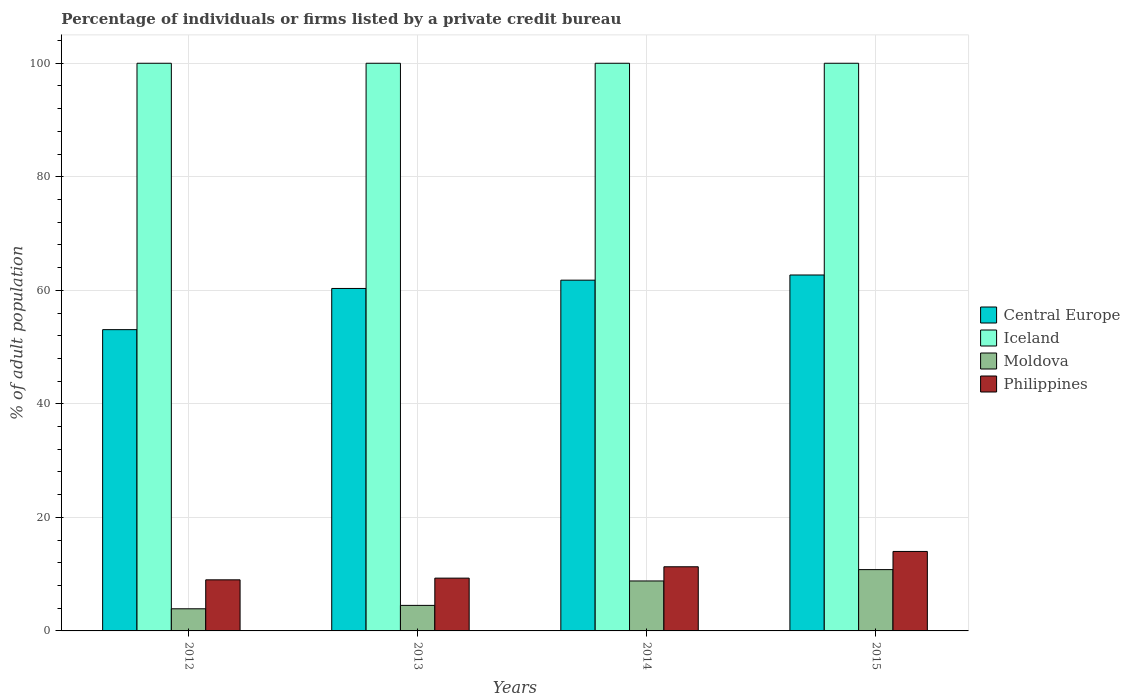How many different coloured bars are there?
Provide a short and direct response. 4. How many groups of bars are there?
Provide a short and direct response. 4. Are the number of bars per tick equal to the number of legend labels?
Provide a succinct answer. Yes. How many bars are there on the 1st tick from the left?
Your response must be concise. 4. How many bars are there on the 3rd tick from the right?
Offer a very short reply. 4. In how many cases, is the number of bars for a given year not equal to the number of legend labels?
Ensure brevity in your answer.  0. Across all years, what is the maximum percentage of population listed by a private credit bureau in Moldova?
Your response must be concise. 10.8. Across all years, what is the minimum percentage of population listed by a private credit bureau in Iceland?
Provide a short and direct response. 100. In which year was the percentage of population listed by a private credit bureau in Central Europe maximum?
Ensure brevity in your answer.  2015. What is the total percentage of population listed by a private credit bureau in Philippines in the graph?
Offer a very short reply. 43.6. What is the difference between the percentage of population listed by a private credit bureau in Philippines in 2014 and that in 2015?
Make the answer very short. -2.7. What is the difference between the percentage of population listed by a private credit bureau in Central Europe in 2015 and the percentage of population listed by a private credit bureau in Moldova in 2013?
Your answer should be very brief. 58.2. What is the average percentage of population listed by a private credit bureau in Philippines per year?
Give a very brief answer. 10.9. In the year 2012, what is the difference between the percentage of population listed by a private credit bureau in Philippines and percentage of population listed by a private credit bureau in Moldova?
Give a very brief answer. 5.1. What is the ratio of the percentage of population listed by a private credit bureau in Iceland in 2012 to that in 2015?
Give a very brief answer. 1. Is the difference between the percentage of population listed by a private credit bureau in Philippines in 2012 and 2014 greater than the difference between the percentage of population listed by a private credit bureau in Moldova in 2012 and 2014?
Your response must be concise. Yes. What is the difference between the highest and the second highest percentage of population listed by a private credit bureau in Philippines?
Your answer should be very brief. 2.7. What is the difference between the highest and the lowest percentage of population listed by a private credit bureau in Central Europe?
Make the answer very short. 9.63. Is it the case that in every year, the sum of the percentage of population listed by a private credit bureau in Iceland and percentage of population listed by a private credit bureau in Philippines is greater than the sum of percentage of population listed by a private credit bureau in Central Europe and percentage of population listed by a private credit bureau in Moldova?
Offer a terse response. Yes. What does the 3rd bar from the left in 2015 represents?
Provide a short and direct response. Moldova. What does the 4th bar from the right in 2015 represents?
Offer a terse response. Central Europe. Is it the case that in every year, the sum of the percentage of population listed by a private credit bureau in Philippines and percentage of population listed by a private credit bureau in Moldova is greater than the percentage of population listed by a private credit bureau in Iceland?
Provide a short and direct response. No. Are all the bars in the graph horizontal?
Offer a very short reply. No. How many years are there in the graph?
Give a very brief answer. 4. What is the difference between two consecutive major ticks on the Y-axis?
Offer a very short reply. 20. Where does the legend appear in the graph?
Offer a terse response. Center right. What is the title of the graph?
Your answer should be compact. Percentage of individuals or firms listed by a private credit bureau. What is the label or title of the Y-axis?
Provide a succinct answer. % of adult population. What is the % of adult population of Central Europe in 2012?
Offer a very short reply. 53.07. What is the % of adult population of Central Europe in 2013?
Offer a terse response. 60.33. What is the % of adult population of Moldova in 2013?
Provide a short and direct response. 4.5. What is the % of adult population of Philippines in 2013?
Offer a terse response. 9.3. What is the % of adult population in Central Europe in 2014?
Offer a very short reply. 61.79. What is the % of adult population of Central Europe in 2015?
Offer a very short reply. 62.7. Across all years, what is the maximum % of adult population of Central Europe?
Your answer should be very brief. 62.7. Across all years, what is the maximum % of adult population of Philippines?
Your answer should be compact. 14. Across all years, what is the minimum % of adult population of Central Europe?
Provide a short and direct response. 53.07. Across all years, what is the minimum % of adult population of Moldova?
Give a very brief answer. 3.9. Across all years, what is the minimum % of adult population of Philippines?
Offer a very short reply. 9. What is the total % of adult population in Central Europe in the graph?
Offer a terse response. 237.89. What is the total % of adult population in Philippines in the graph?
Make the answer very short. 43.6. What is the difference between the % of adult population in Central Europe in 2012 and that in 2013?
Make the answer very short. -7.25. What is the difference between the % of adult population of Moldova in 2012 and that in 2013?
Provide a succinct answer. -0.6. What is the difference between the % of adult population in Central Europe in 2012 and that in 2014?
Make the answer very short. -8.72. What is the difference between the % of adult population in Iceland in 2012 and that in 2014?
Your answer should be compact. 0. What is the difference between the % of adult population in Moldova in 2012 and that in 2014?
Provide a short and direct response. -4.9. What is the difference between the % of adult population in Central Europe in 2012 and that in 2015?
Ensure brevity in your answer.  -9.63. What is the difference between the % of adult population of Iceland in 2012 and that in 2015?
Provide a succinct answer. 0. What is the difference between the % of adult population of Moldova in 2012 and that in 2015?
Make the answer very short. -6.9. What is the difference between the % of adult population of Central Europe in 2013 and that in 2014?
Offer a very short reply. -1.46. What is the difference between the % of adult population of Central Europe in 2013 and that in 2015?
Give a very brief answer. -2.37. What is the difference between the % of adult population of Iceland in 2013 and that in 2015?
Your response must be concise. 0. What is the difference between the % of adult population of Moldova in 2013 and that in 2015?
Ensure brevity in your answer.  -6.3. What is the difference between the % of adult population in Philippines in 2013 and that in 2015?
Your response must be concise. -4.7. What is the difference between the % of adult population in Central Europe in 2014 and that in 2015?
Provide a short and direct response. -0.91. What is the difference between the % of adult population in Moldova in 2014 and that in 2015?
Give a very brief answer. -2. What is the difference between the % of adult population of Central Europe in 2012 and the % of adult population of Iceland in 2013?
Keep it short and to the point. -46.93. What is the difference between the % of adult population of Central Europe in 2012 and the % of adult population of Moldova in 2013?
Provide a succinct answer. 48.57. What is the difference between the % of adult population of Central Europe in 2012 and the % of adult population of Philippines in 2013?
Your answer should be very brief. 43.77. What is the difference between the % of adult population in Iceland in 2012 and the % of adult population in Moldova in 2013?
Keep it short and to the point. 95.5. What is the difference between the % of adult population in Iceland in 2012 and the % of adult population in Philippines in 2013?
Give a very brief answer. 90.7. What is the difference between the % of adult population in Moldova in 2012 and the % of adult population in Philippines in 2013?
Offer a terse response. -5.4. What is the difference between the % of adult population of Central Europe in 2012 and the % of adult population of Iceland in 2014?
Keep it short and to the point. -46.93. What is the difference between the % of adult population in Central Europe in 2012 and the % of adult population in Moldova in 2014?
Your answer should be very brief. 44.27. What is the difference between the % of adult population of Central Europe in 2012 and the % of adult population of Philippines in 2014?
Your answer should be compact. 41.77. What is the difference between the % of adult population in Iceland in 2012 and the % of adult population in Moldova in 2014?
Your answer should be very brief. 91.2. What is the difference between the % of adult population in Iceland in 2012 and the % of adult population in Philippines in 2014?
Your response must be concise. 88.7. What is the difference between the % of adult population in Central Europe in 2012 and the % of adult population in Iceland in 2015?
Keep it short and to the point. -46.93. What is the difference between the % of adult population in Central Europe in 2012 and the % of adult population in Moldova in 2015?
Offer a terse response. 42.27. What is the difference between the % of adult population of Central Europe in 2012 and the % of adult population of Philippines in 2015?
Ensure brevity in your answer.  39.07. What is the difference between the % of adult population in Iceland in 2012 and the % of adult population in Moldova in 2015?
Provide a succinct answer. 89.2. What is the difference between the % of adult population in Moldova in 2012 and the % of adult population in Philippines in 2015?
Give a very brief answer. -10.1. What is the difference between the % of adult population of Central Europe in 2013 and the % of adult population of Iceland in 2014?
Provide a succinct answer. -39.67. What is the difference between the % of adult population of Central Europe in 2013 and the % of adult population of Moldova in 2014?
Your answer should be compact. 51.53. What is the difference between the % of adult population of Central Europe in 2013 and the % of adult population of Philippines in 2014?
Provide a short and direct response. 49.03. What is the difference between the % of adult population of Iceland in 2013 and the % of adult population of Moldova in 2014?
Ensure brevity in your answer.  91.2. What is the difference between the % of adult population in Iceland in 2013 and the % of adult population in Philippines in 2014?
Make the answer very short. 88.7. What is the difference between the % of adult population in Moldova in 2013 and the % of adult population in Philippines in 2014?
Your answer should be compact. -6.8. What is the difference between the % of adult population in Central Europe in 2013 and the % of adult population in Iceland in 2015?
Keep it short and to the point. -39.67. What is the difference between the % of adult population of Central Europe in 2013 and the % of adult population of Moldova in 2015?
Offer a very short reply. 49.53. What is the difference between the % of adult population in Central Europe in 2013 and the % of adult population in Philippines in 2015?
Offer a very short reply. 46.33. What is the difference between the % of adult population in Iceland in 2013 and the % of adult population in Moldova in 2015?
Your answer should be compact. 89.2. What is the difference between the % of adult population in Central Europe in 2014 and the % of adult population in Iceland in 2015?
Give a very brief answer. -38.21. What is the difference between the % of adult population in Central Europe in 2014 and the % of adult population in Moldova in 2015?
Your answer should be very brief. 50.99. What is the difference between the % of adult population of Central Europe in 2014 and the % of adult population of Philippines in 2015?
Ensure brevity in your answer.  47.79. What is the difference between the % of adult population of Iceland in 2014 and the % of adult population of Moldova in 2015?
Offer a terse response. 89.2. What is the difference between the % of adult population in Iceland in 2014 and the % of adult population in Philippines in 2015?
Provide a succinct answer. 86. What is the difference between the % of adult population in Moldova in 2014 and the % of adult population in Philippines in 2015?
Ensure brevity in your answer.  -5.2. What is the average % of adult population of Central Europe per year?
Offer a terse response. 59.47. In the year 2012, what is the difference between the % of adult population of Central Europe and % of adult population of Iceland?
Offer a terse response. -46.93. In the year 2012, what is the difference between the % of adult population in Central Europe and % of adult population in Moldova?
Offer a very short reply. 49.17. In the year 2012, what is the difference between the % of adult population of Central Europe and % of adult population of Philippines?
Your answer should be compact. 44.07. In the year 2012, what is the difference between the % of adult population in Iceland and % of adult population in Moldova?
Provide a short and direct response. 96.1. In the year 2012, what is the difference between the % of adult population in Iceland and % of adult population in Philippines?
Ensure brevity in your answer.  91. In the year 2012, what is the difference between the % of adult population of Moldova and % of adult population of Philippines?
Give a very brief answer. -5.1. In the year 2013, what is the difference between the % of adult population of Central Europe and % of adult population of Iceland?
Provide a short and direct response. -39.67. In the year 2013, what is the difference between the % of adult population in Central Europe and % of adult population in Moldova?
Provide a succinct answer. 55.83. In the year 2013, what is the difference between the % of adult population of Central Europe and % of adult population of Philippines?
Your answer should be very brief. 51.03. In the year 2013, what is the difference between the % of adult population in Iceland and % of adult population in Moldova?
Your answer should be compact. 95.5. In the year 2013, what is the difference between the % of adult population of Iceland and % of adult population of Philippines?
Give a very brief answer. 90.7. In the year 2014, what is the difference between the % of adult population in Central Europe and % of adult population in Iceland?
Offer a very short reply. -38.21. In the year 2014, what is the difference between the % of adult population in Central Europe and % of adult population in Moldova?
Offer a very short reply. 52.99. In the year 2014, what is the difference between the % of adult population in Central Europe and % of adult population in Philippines?
Your answer should be compact. 50.49. In the year 2014, what is the difference between the % of adult population of Iceland and % of adult population of Moldova?
Ensure brevity in your answer.  91.2. In the year 2014, what is the difference between the % of adult population in Iceland and % of adult population in Philippines?
Your answer should be compact. 88.7. In the year 2014, what is the difference between the % of adult population in Moldova and % of adult population in Philippines?
Give a very brief answer. -2.5. In the year 2015, what is the difference between the % of adult population in Central Europe and % of adult population in Iceland?
Ensure brevity in your answer.  -37.3. In the year 2015, what is the difference between the % of adult population of Central Europe and % of adult population of Moldova?
Your answer should be compact. 51.9. In the year 2015, what is the difference between the % of adult population of Central Europe and % of adult population of Philippines?
Your answer should be compact. 48.7. In the year 2015, what is the difference between the % of adult population in Iceland and % of adult population in Moldova?
Your answer should be compact. 89.2. In the year 2015, what is the difference between the % of adult population of Iceland and % of adult population of Philippines?
Keep it short and to the point. 86. What is the ratio of the % of adult population of Central Europe in 2012 to that in 2013?
Offer a very short reply. 0.88. What is the ratio of the % of adult population in Iceland in 2012 to that in 2013?
Offer a very short reply. 1. What is the ratio of the % of adult population of Moldova in 2012 to that in 2013?
Ensure brevity in your answer.  0.87. What is the ratio of the % of adult population of Central Europe in 2012 to that in 2014?
Your response must be concise. 0.86. What is the ratio of the % of adult population of Moldova in 2012 to that in 2014?
Provide a succinct answer. 0.44. What is the ratio of the % of adult population of Philippines in 2012 to that in 2014?
Offer a terse response. 0.8. What is the ratio of the % of adult population of Central Europe in 2012 to that in 2015?
Give a very brief answer. 0.85. What is the ratio of the % of adult population of Moldova in 2012 to that in 2015?
Give a very brief answer. 0.36. What is the ratio of the % of adult population in Philippines in 2012 to that in 2015?
Give a very brief answer. 0.64. What is the ratio of the % of adult population in Central Europe in 2013 to that in 2014?
Make the answer very short. 0.98. What is the ratio of the % of adult population in Iceland in 2013 to that in 2014?
Provide a succinct answer. 1. What is the ratio of the % of adult population of Moldova in 2013 to that in 2014?
Give a very brief answer. 0.51. What is the ratio of the % of adult population in Philippines in 2013 to that in 2014?
Make the answer very short. 0.82. What is the ratio of the % of adult population of Central Europe in 2013 to that in 2015?
Offer a very short reply. 0.96. What is the ratio of the % of adult population in Moldova in 2013 to that in 2015?
Offer a terse response. 0.42. What is the ratio of the % of adult population of Philippines in 2013 to that in 2015?
Your answer should be compact. 0.66. What is the ratio of the % of adult population of Central Europe in 2014 to that in 2015?
Keep it short and to the point. 0.99. What is the ratio of the % of adult population of Iceland in 2014 to that in 2015?
Give a very brief answer. 1. What is the ratio of the % of adult population in Moldova in 2014 to that in 2015?
Keep it short and to the point. 0.81. What is the ratio of the % of adult population of Philippines in 2014 to that in 2015?
Your answer should be very brief. 0.81. What is the difference between the highest and the second highest % of adult population in Central Europe?
Keep it short and to the point. 0.91. What is the difference between the highest and the second highest % of adult population in Moldova?
Your answer should be compact. 2. What is the difference between the highest and the second highest % of adult population of Philippines?
Your response must be concise. 2.7. What is the difference between the highest and the lowest % of adult population in Central Europe?
Give a very brief answer. 9.63. What is the difference between the highest and the lowest % of adult population of Iceland?
Make the answer very short. 0. What is the difference between the highest and the lowest % of adult population of Philippines?
Make the answer very short. 5. 